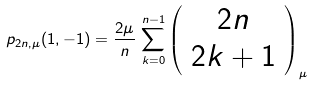Convert formula to latex. <formula><loc_0><loc_0><loc_500><loc_500>p _ { 2 n , \mu } ( 1 , - 1 ) = \frac { 2 \mu } { n } \, \sum _ { k = 0 } ^ { n - 1 } \left ( \begin{array} { c } 2 n \\ 2 k + 1 \end{array} \right ) _ { \mu }</formula> 